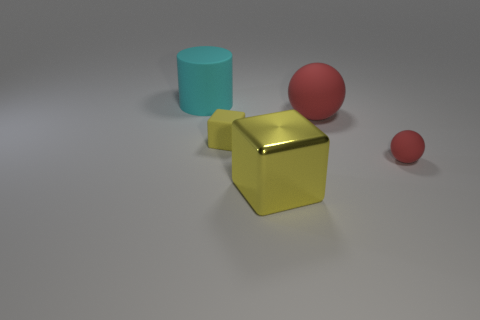There is a metallic object; is its shape the same as the big red matte object behind the tiny yellow matte object?
Give a very brief answer. No. Is the number of cyan rubber cylinders in front of the large red ball less than the number of red matte balls to the left of the large rubber cylinder?
Offer a very short reply. No. What material is the small red object that is the same shape as the big red matte object?
Ensure brevity in your answer.  Rubber. Is there anything else that is made of the same material as the big red sphere?
Keep it short and to the point. Yes. Does the matte cylinder have the same color as the tiny rubber ball?
Your answer should be very brief. No. What is the shape of the tiny yellow thing that is made of the same material as the large cyan cylinder?
Make the answer very short. Cube. What number of cyan objects have the same shape as the tiny yellow matte object?
Offer a terse response. 0. There is a tiny thing that is to the left of the large object that is in front of the small red matte ball; what shape is it?
Keep it short and to the point. Cube. There is a yellow object behind the yellow metal object; is it the same size as the large cyan cylinder?
Offer a very short reply. No. There is a rubber thing that is both to the left of the large yellow metallic block and in front of the large rubber cylinder; what size is it?
Offer a terse response. Small. 